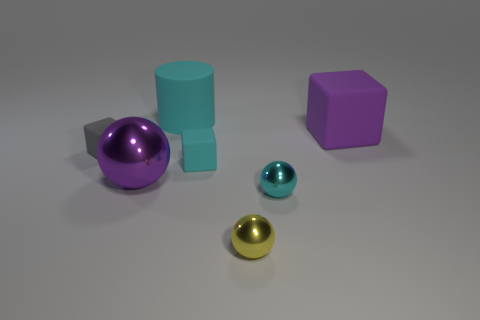What number of other things are there of the same material as the cyan cylinder
Ensure brevity in your answer.  3. The tiny rubber thing that is the same color as the large matte cylinder is what shape?
Ensure brevity in your answer.  Cube. What size is the purple thing in front of the small cyan rubber object?
Provide a short and direct response. Large. The tiny cyan thing that is made of the same material as the purple cube is what shape?
Ensure brevity in your answer.  Cube. Does the gray block have the same material as the tiny cube to the right of the big rubber cylinder?
Your answer should be compact. Yes. Do the cyan rubber object that is behind the tiny gray thing and the gray thing have the same shape?
Keep it short and to the point. No. There is another small thing that is the same shape as the yellow metallic thing; what material is it?
Keep it short and to the point. Metal. Does the small gray object have the same shape as the large matte object in front of the cyan matte cylinder?
Provide a short and direct response. Yes. What is the color of the tiny object that is behind the yellow shiny sphere and in front of the purple metallic object?
Keep it short and to the point. Cyan. Are there any cylinders?
Offer a terse response. Yes. 